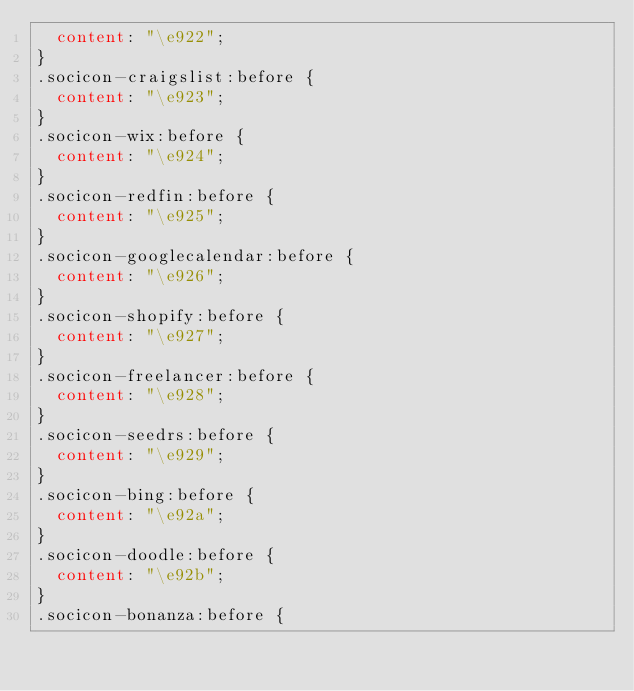<code> <loc_0><loc_0><loc_500><loc_500><_CSS_>  content: "\e922";
}
.socicon-craigslist:before {
  content: "\e923";
}
.socicon-wix:before {
  content: "\e924";
}
.socicon-redfin:before {
  content: "\e925";
}
.socicon-googlecalendar:before {
  content: "\e926";
}
.socicon-shopify:before {
  content: "\e927";
}
.socicon-freelancer:before {
  content: "\e928";
}
.socicon-seedrs:before {
  content: "\e929";
}
.socicon-bing:before {
  content: "\e92a";
}
.socicon-doodle:before {
  content: "\e92b";
}
.socicon-bonanza:before {</code> 